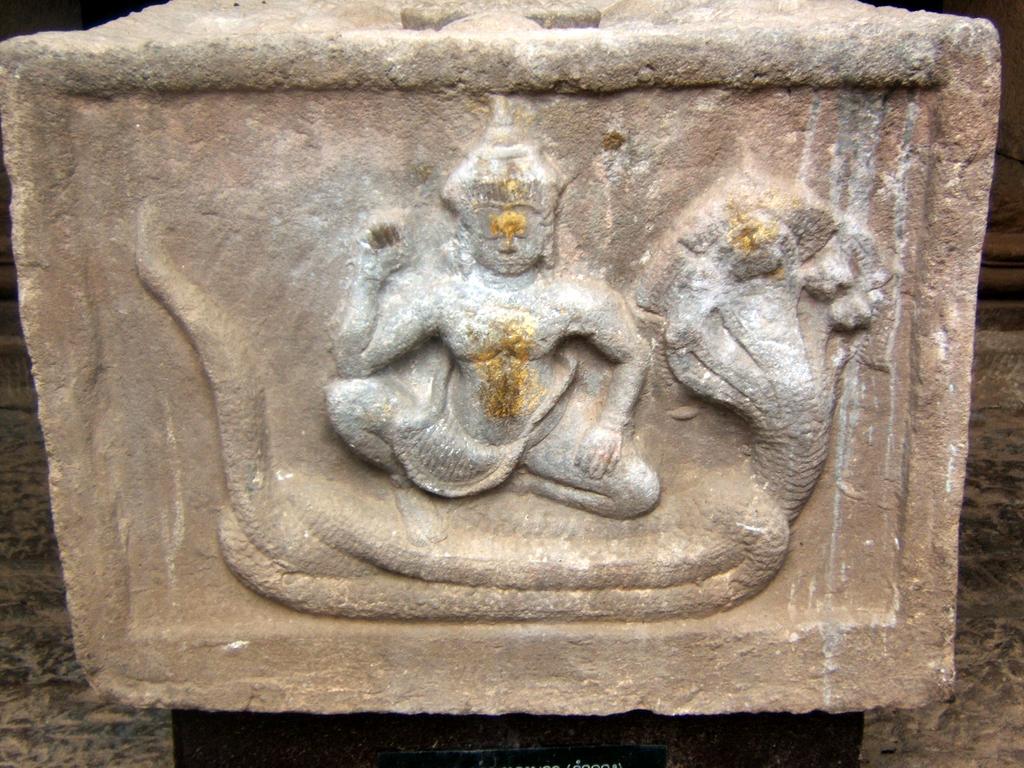How would you summarize this image in a sentence or two? In this image we can see rock-art of lord and snake which is on rock. 